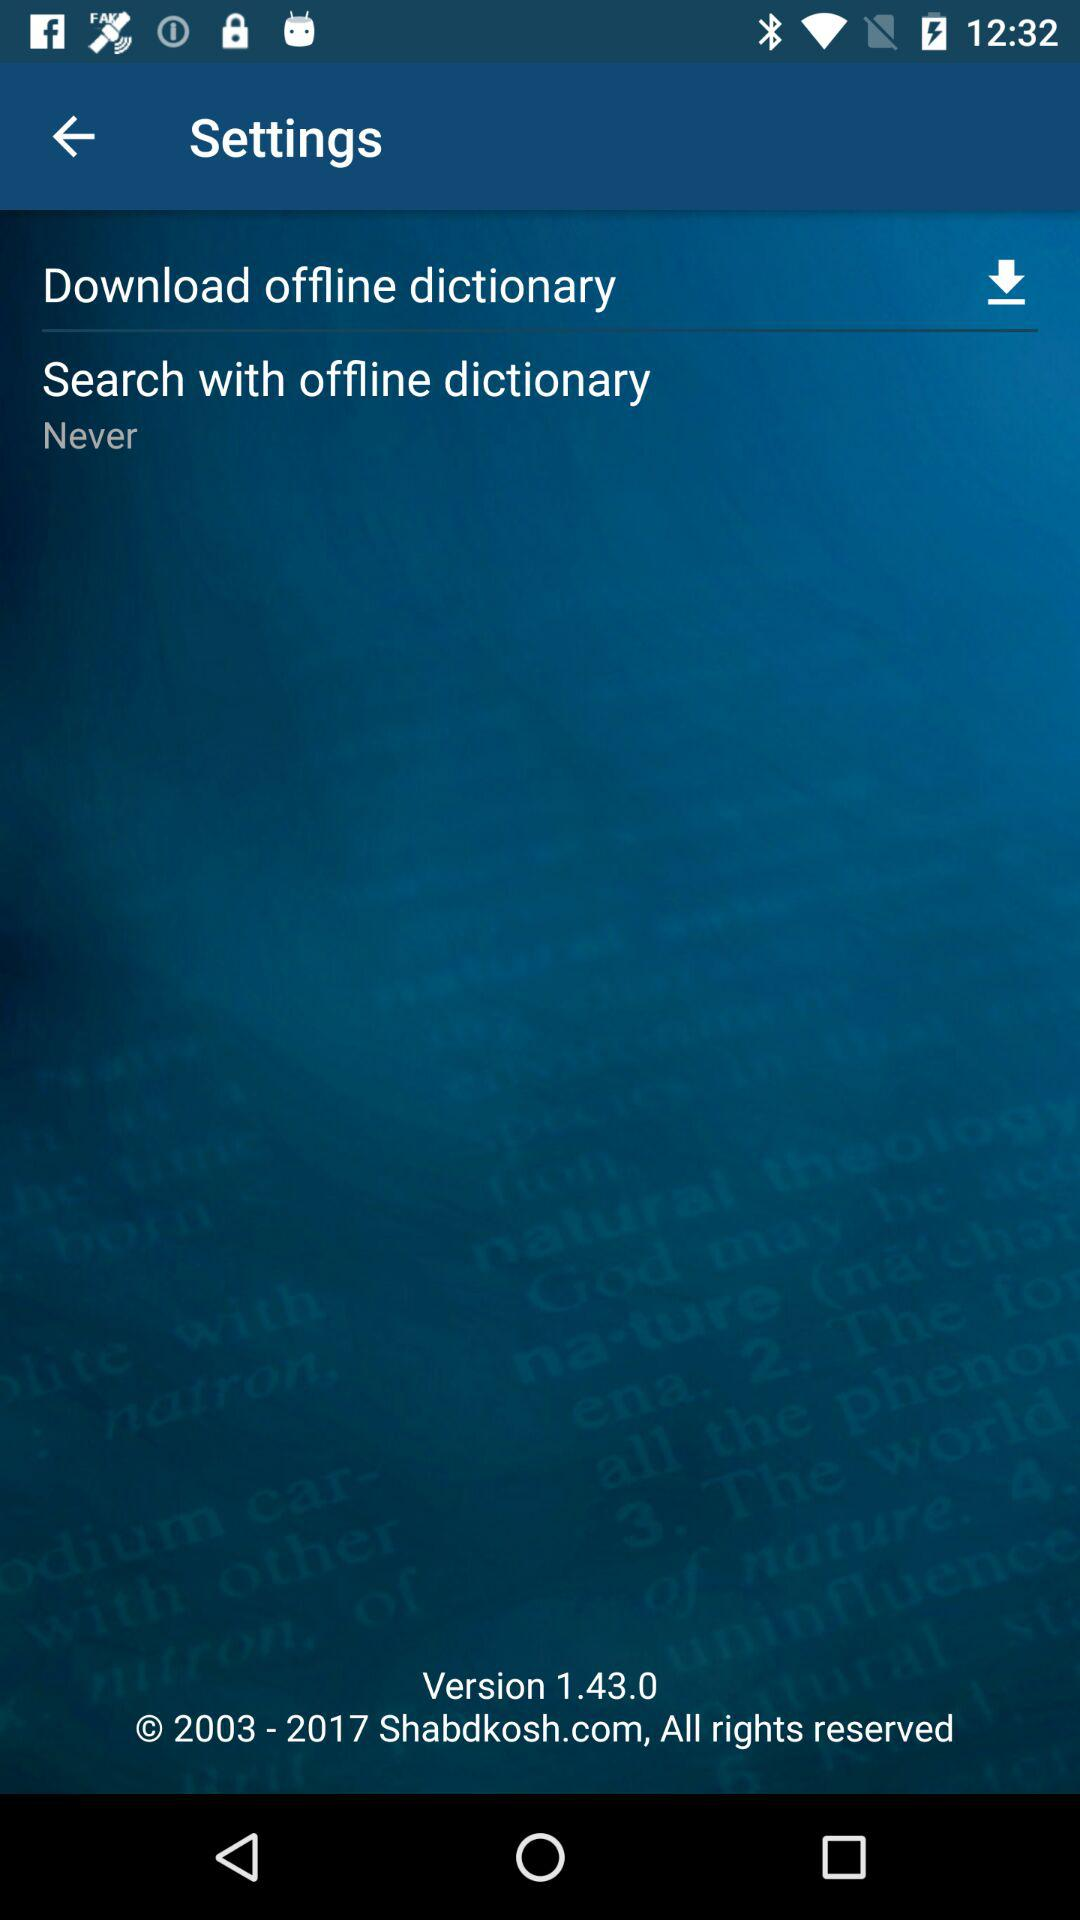What is the version? The version is 1.43.0. 